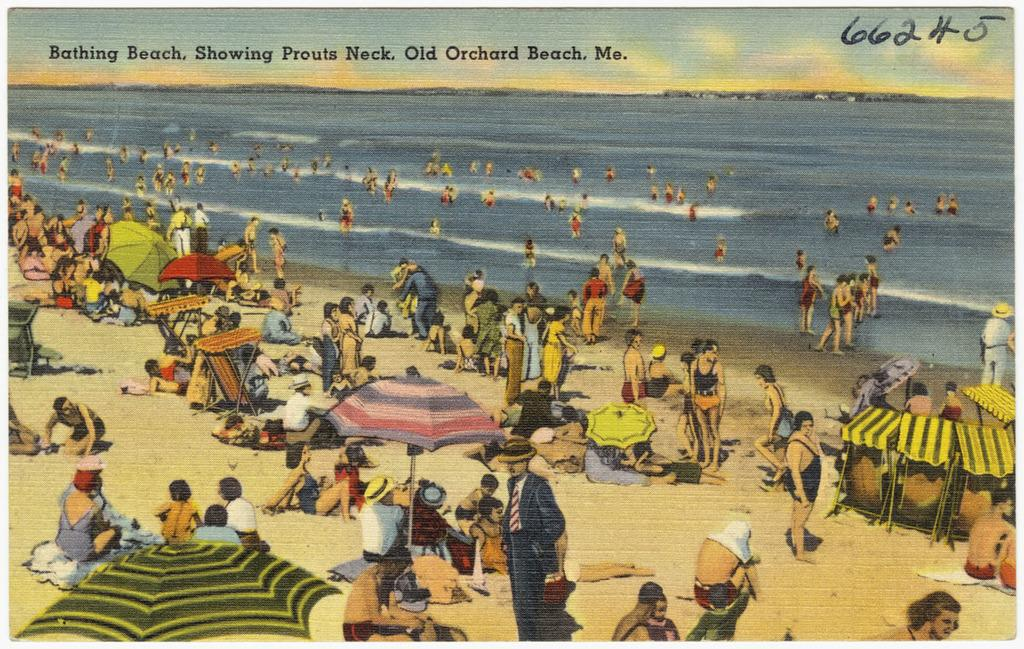<image>
Write a terse but informative summary of the picture. A old picture of a beach scene at Bathing Beach in Old Orchard Beach, Maine 